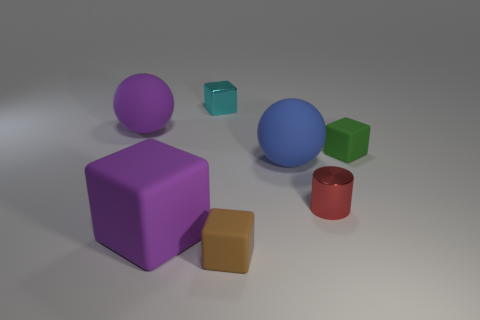There is a metallic thing that is behind the purple matte sphere; does it have the same size as the purple thing in front of the blue matte object?
Offer a terse response. No. What color is the small matte cube behind the red cylinder?
Make the answer very short. Green. Is the number of red objects that are behind the tiny red metallic cylinder less than the number of red matte blocks?
Ensure brevity in your answer.  No. Is the large cube made of the same material as the cyan thing?
Your answer should be very brief. No. What size is the cyan shiny thing that is the same shape as the small brown object?
Offer a very short reply. Small. What number of things are either large objects behind the large purple cube or things to the left of the shiny cube?
Ensure brevity in your answer.  3. Is the number of green objects less than the number of big cyan cubes?
Ensure brevity in your answer.  No. Is the size of the metal block the same as the sphere on the left side of the cyan cube?
Make the answer very short. No. What number of metallic objects are either cyan cubes or tiny gray objects?
Offer a very short reply. 1. Are there more red shiny balls than rubber cubes?
Provide a short and direct response. No. 